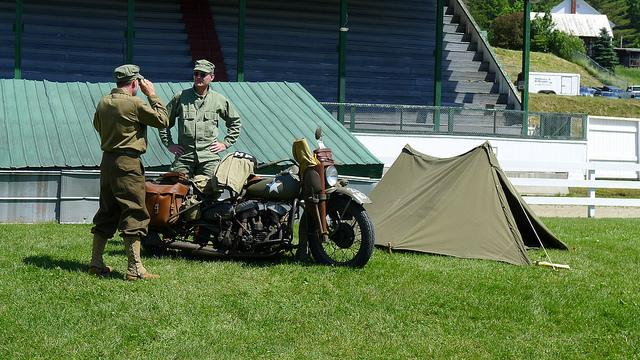Which one is the superior officer? Please explain your reasoning. facing camera. The officer faces the camera. 